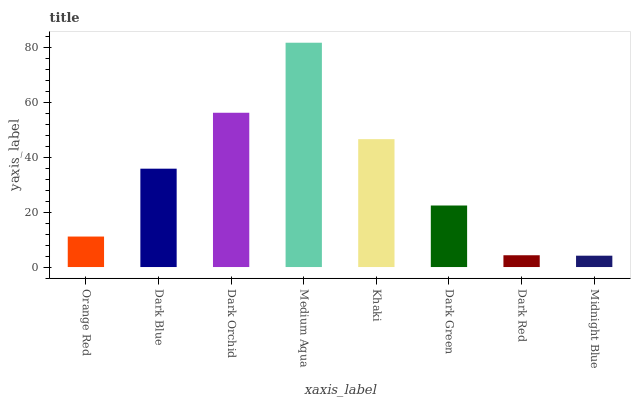Is Midnight Blue the minimum?
Answer yes or no. Yes. Is Medium Aqua the maximum?
Answer yes or no. Yes. Is Dark Blue the minimum?
Answer yes or no. No. Is Dark Blue the maximum?
Answer yes or no. No. Is Dark Blue greater than Orange Red?
Answer yes or no. Yes. Is Orange Red less than Dark Blue?
Answer yes or no. Yes. Is Orange Red greater than Dark Blue?
Answer yes or no. No. Is Dark Blue less than Orange Red?
Answer yes or no. No. Is Dark Blue the high median?
Answer yes or no. Yes. Is Dark Green the low median?
Answer yes or no. Yes. Is Dark Green the high median?
Answer yes or no. No. Is Khaki the low median?
Answer yes or no. No. 